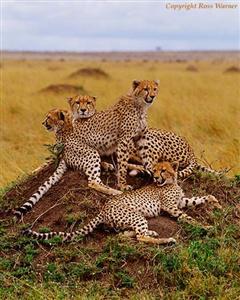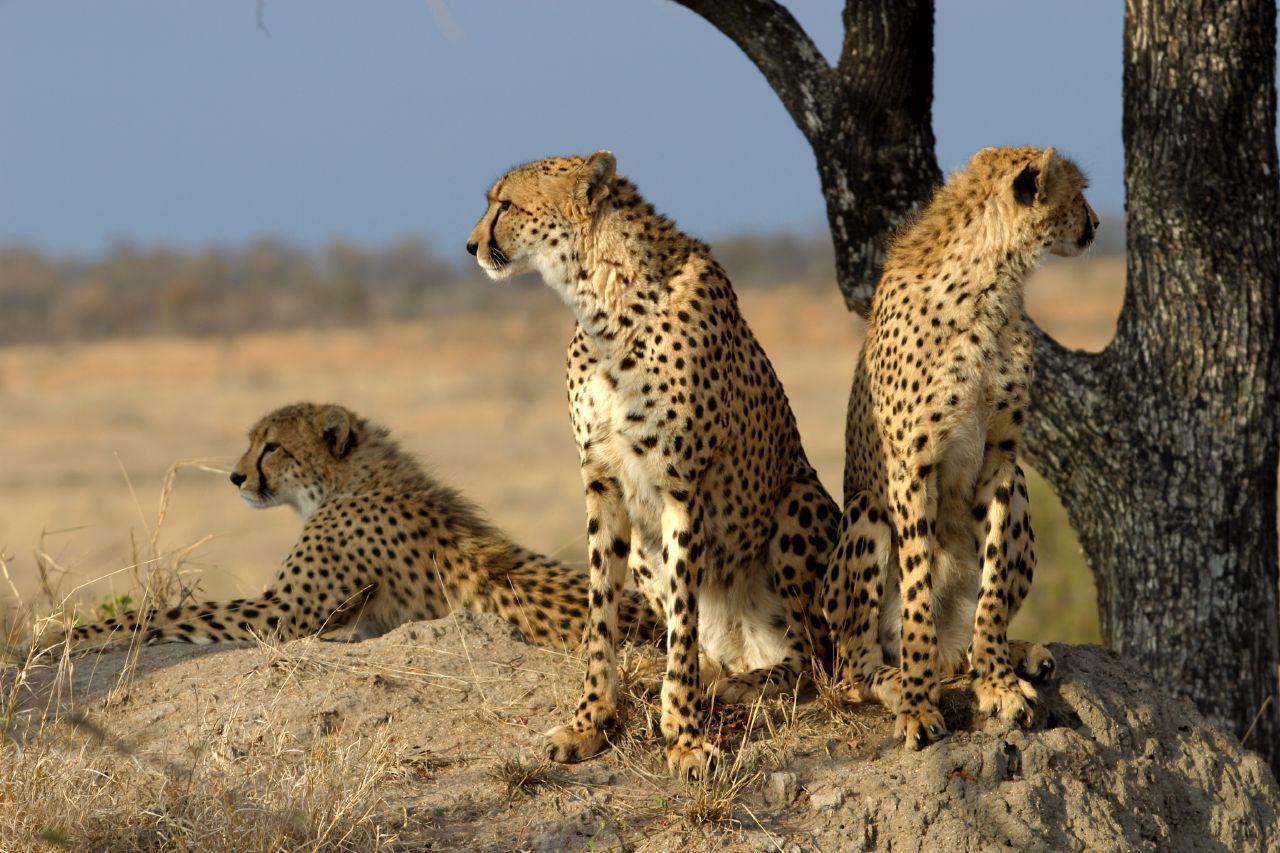The first image is the image on the left, the second image is the image on the right. For the images displayed, is the sentence "An image depicts just one cheetah, which is in a leaping pose." factually correct? Answer yes or no. No. 